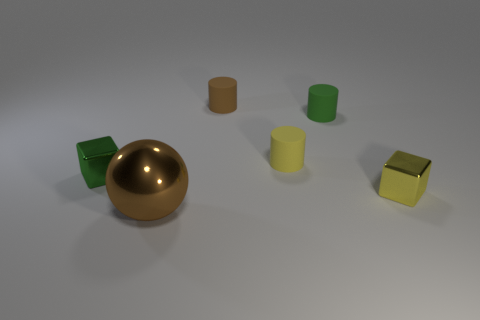Add 3 yellow metallic cubes. How many objects exist? 9 Subtract all cubes. How many objects are left? 4 Add 6 large spheres. How many large spheres exist? 7 Subtract 0 yellow spheres. How many objects are left? 6 Subtract all matte cylinders. Subtract all small metallic blocks. How many objects are left? 1 Add 4 green metal blocks. How many green metal blocks are left? 5 